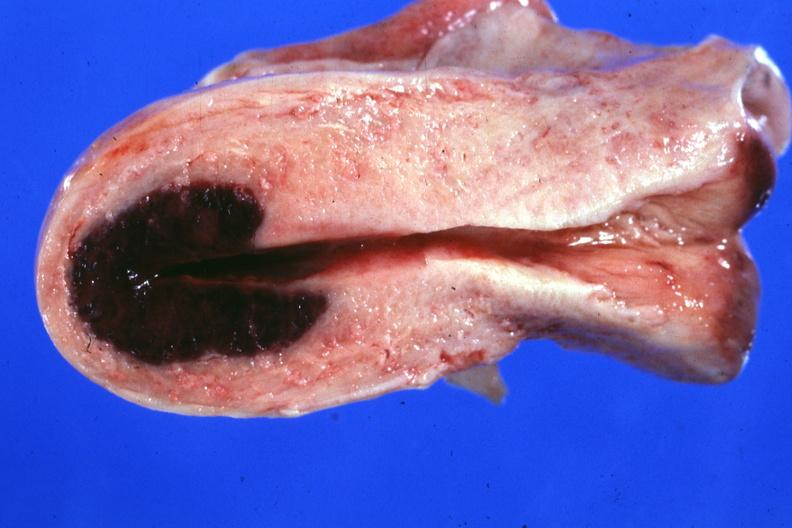s adenosis and ischemia present?
Answer the question using a single word or phrase. Yes 